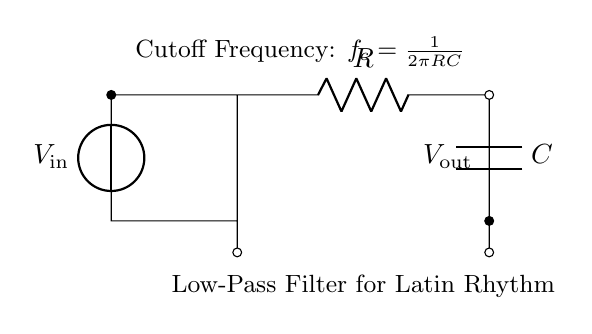What is the input voltage for this circuit? The input voltage is represented by the label V_in on the circuit diagram, which is the voltage supplied to the filter.
Answer: V_in What is the purpose of the capacitor in this circuit? The capacitor, labeled C in the diagram, is used to allow AC signals to pass while blocking DC components, which is essential for filtering out unwanted high frequencies.
Answer: To filter high frequencies What is the cutoff frequency formula shown in the circuit? The circuit diagram includes a note stating the formula for cutoff frequency: fc equals one divided by two times pi times R times C, meaning that the cutoff frequency is determined by the resistance and capacitance values.
Answer: fc = 1/(2πRC) What happens to frequencies above the cutoff frequency in this filter? Frequencies above the cutoff frequency are attenuated or reduced in amplitude, allowing only lower frequencies to pass through to the output.
Answer: They are attenuated What is the output voltage denoted in the circuit? The output voltage is indicated by V_out in the diagram, showing where the filtered signal is taken from.
Answer: V_out How does increasing the resistance R affect the cutoff frequency? Increasing resistance R will lower the cutoff frequency, as per the formula shown, which indicates that a higher resistance means a lower frequency at which the filter starts to affect signal amplitude.
Answer: It lowers the cutoff frequency 